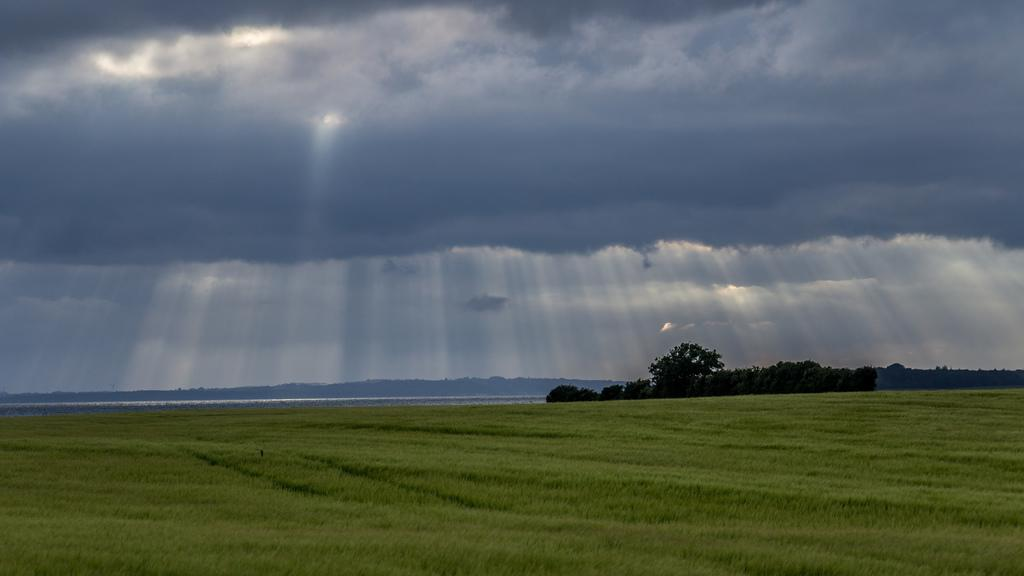What type of vegetation is present in the image? There is grass and trees in the image. What geographical feature can be seen in the background of the image? There are mountains in the image. What part of the natural environment is visible in the image? The sky is visible in the image. What type of location might the image depict? The image may have been taken on a farm. At what time of day might the image have been taken? The image may have been taken during the day. What type of pocket can be seen on the goat in the image? There is no goat present in the image, and therefore no pocket can be seen. 